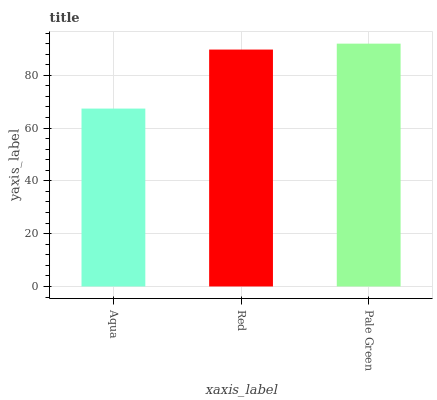Is Aqua the minimum?
Answer yes or no. Yes. Is Pale Green the maximum?
Answer yes or no. Yes. Is Red the minimum?
Answer yes or no. No. Is Red the maximum?
Answer yes or no. No. Is Red greater than Aqua?
Answer yes or no. Yes. Is Aqua less than Red?
Answer yes or no. Yes. Is Aqua greater than Red?
Answer yes or no. No. Is Red less than Aqua?
Answer yes or no. No. Is Red the high median?
Answer yes or no. Yes. Is Red the low median?
Answer yes or no. Yes. Is Aqua the high median?
Answer yes or no. No. Is Aqua the low median?
Answer yes or no. No. 